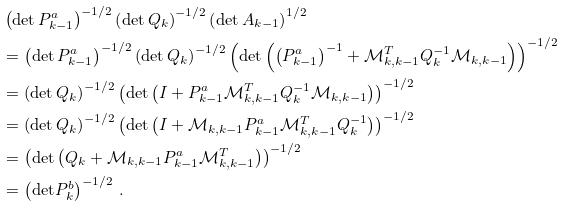<formula> <loc_0><loc_0><loc_500><loc_500>& \left ( \text {det} \, P _ { k - 1 } ^ { a } \right ) ^ { - 1 / 2 } \left ( \text {det} \, Q _ { k } \right ) ^ { - 1 / 2 } \left ( \text {det} \, A _ { k - 1 } \right ) ^ { 1 / 2 } \\ & = \left ( \text {det} \, P _ { k - 1 } ^ { a } \right ) ^ { - 1 / 2 } \left ( \text {det} \, Q _ { k } \right ) ^ { - 1 / 2 } \left ( \text {det} \left ( \left ( P _ { k - 1 } ^ { a } \right ) ^ { - 1 } + \mathcal { M } _ { k , k - 1 } ^ { T } Q _ { k } ^ { - 1 } \mathcal { M } _ { k , k - 1 } \right ) \right ) ^ { - 1 / 2 } \\ & = \left ( \text {det} \, Q _ { k } \right ) ^ { - 1 / 2 } \left ( \text {det} \left ( I + P _ { k - 1 } ^ { a } \mathcal { M } _ { k , k - 1 } ^ { T } Q _ { k } ^ { - 1 } \mathcal { M } _ { k , k - 1 } \right ) \right ) ^ { - 1 / 2 } \\ & = \left ( \text {det} \, Q _ { k } \right ) ^ { - 1 / 2 } \left ( \text {det} \left ( I + \mathcal { M } _ { k , k - 1 } P _ { k - 1 } ^ { a } \mathcal { M } _ { k , k - 1 } ^ { T } Q _ { k } ^ { - 1 } \right ) \right ) ^ { - 1 / 2 } \\ & = \left ( \text {det} \left ( Q _ { k } + \mathcal { M } _ { k , k - 1 } P _ { k - 1 } ^ { a } \mathcal { M } _ { k , k - 1 } ^ { T } \right ) \right ) ^ { - 1 / 2 } \\ & = \left ( \text {det} P _ { k } ^ { b } \right ) ^ { - 1 / 2 } \, .</formula> 